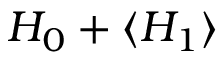Convert formula to latex. <formula><loc_0><loc_0><loc_500><loc_500>H _ { 0 } + \langle H _ { 1 } \rangle</formula> 